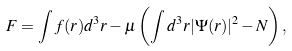<formula> <loc_0><loc_0><loc_500><loc_500>F = \int f ( r ) d ^ { 3 } r - \mu \left ( \int d ^ { 3 } r | \Psi ( { r } ) | ^ { 2 } - N \right ) ,</formula> 